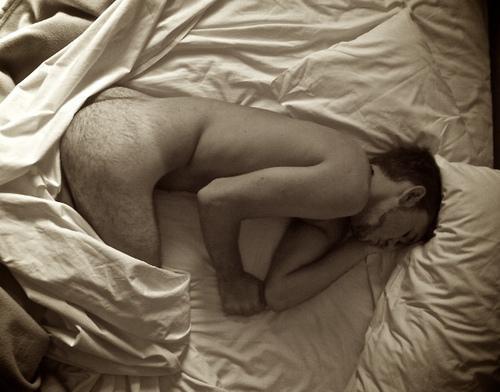How many people are there?
Give a very brief answer. 1. 